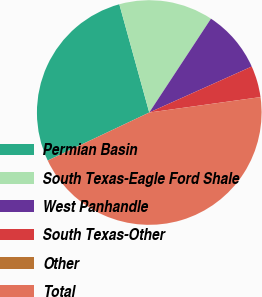Convert chart. <chart><loc_0><loc_0><loc_500><loc_500><pie_chart><fcel>Permian Basin<fcel>South Texas-Eagle Ford Shale<fcel>West Panhandle<fcel>South Texas-Other<fcel>Other<fcel>Total<nl><fcel>27.74%<fcel>13.55%<fcel>9.03%<fcel>4.52%<fcel>0.0%<fcel>45.16%<nl></chart> 